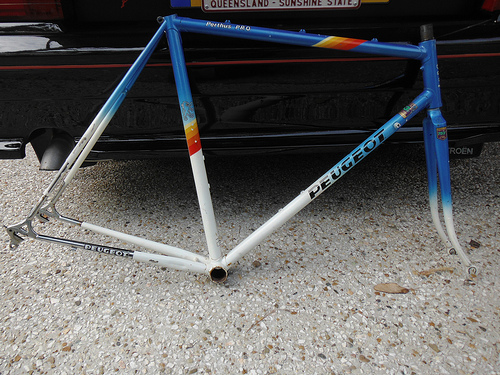<image>
Is the bicycle frame in the ground? Yes. The bicycle frame is contained within or inside the ground, showing a containment relationship. 